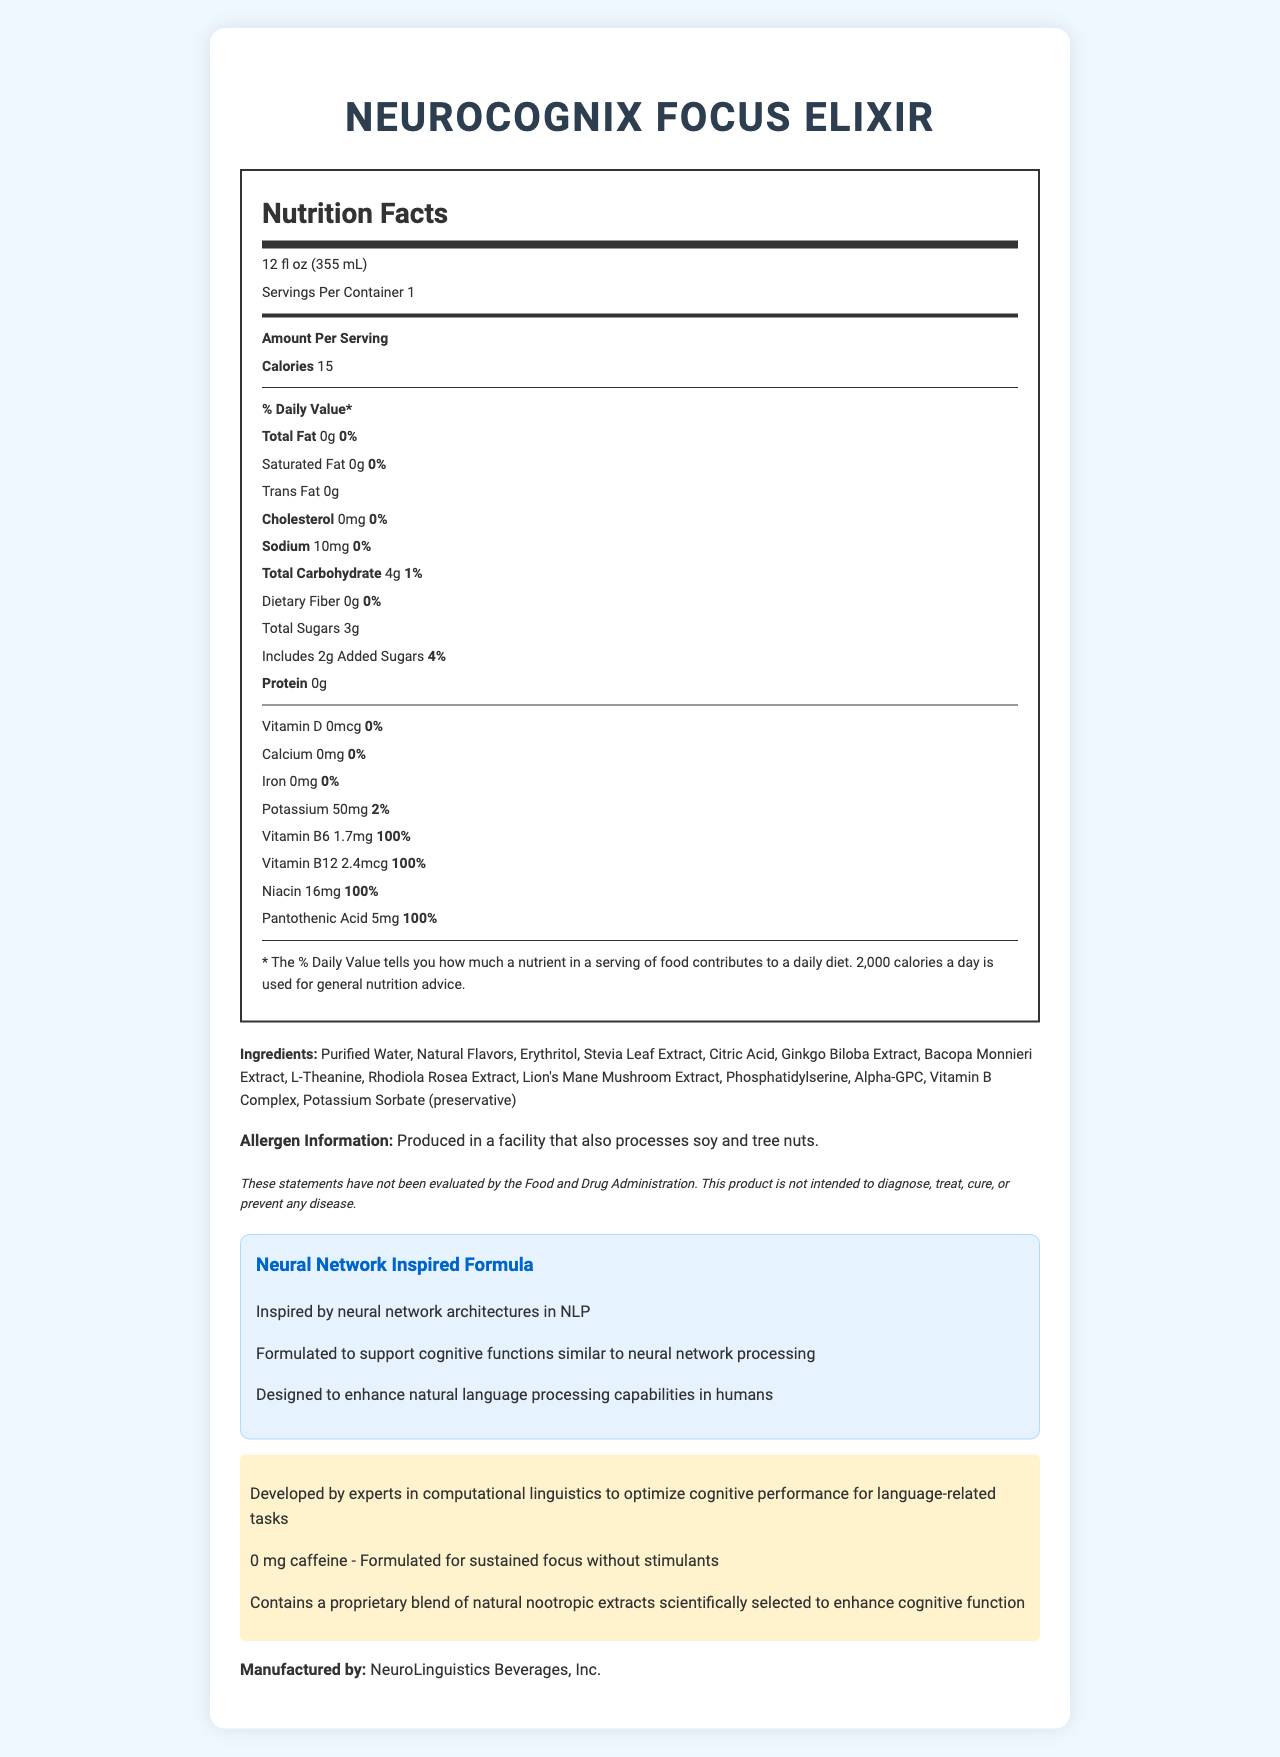What is the serving size for NeuroCognix Focus Elixir? The serving size is explicitly stated at the beginning of the nutrition facts section.
Answer: 12 fl oz (355 mL) What is the amount of total sugars per serving? Underneath the "Total Carbohydrate" section, it lists "Total Sugars 3g."
Answer: 3g How many servings are there per container? The nutrition facts state "Servings Per Container 1."
Answer: 1 What is the percentage daily value of Vitamin B12? The nutrition facts list Vitamin B12 as "100%."
Answer: 100% How much potassium is in one serving of NeuroCognix Focus Elixir? The document lists "Potassium 50mg 2%."
Answer: 50mg Which of the following natural extracts are included in the ingredients? 
A. Echinacea
B. Ginkgo Biloba Extract 
C. Green Tea Extract 
D. Rhodiola Rosea Extract The ingredients list includes "Ginkgo Biloba Extract" and "Rhodiola Rosea Extract."
Answer: B and D What is the calorie count per serving for this beverage? 
1. 0
2. 10
3. 15
4. 20 The nutrition facts state "Calories 15."
Answer: 3 Is NeuroCognix Focus Elixir caffeine-free? The highlighted section mentions "0 mg caffeine - Formulated for sustained focus without stimulants."
Answer: Yes Summarize the main idea of the document. The document comprehensively covers all aspects of the product, from basic nutritional information to the scientific inspiration behind its formulation.
Answer: This document provides the nutrition facts and additional information for NeuroCognix Focus Elixir, a caffeine-free, focus-enhancing beverage with natural extracts. It details the serving size, nutritional content, ingredients, allergen information, manufacturer, and the inspiration behind its formulation rooted in neural network architectures. Does the document mention the inclusion of any artificial preservatives? The ingredients list includes "Potassium Sorbate (preservative)," which is not specified as artificial, similar to natural extracts.
Answer: No What is the dietary fiber content in NeuroCognix Focus Elixir? The nutrition facts state "Dietary Fiber 0g."
Answer: 0g Who is the manufacturer of NeuroCognix Focus Elixir? The manufacturer is specified at the end of the document with "Manufactured by: NeuroLinguistics Beverages, Inc."
Answer: NeuroLinguistics Beverages, Inc. What is the main purpose of the proprietary blend of natural extracts in this beverage? The highlight section states "Contains a proprietary blend of natural nootropic extracts scientifically selected to enhance cognitive function."
Answer: To enhance cognitive function What is the product's connection to computational linguistics? This is explicitly mentioned in the highlighted section of the document.
Answer: Developed by experts in computational linguistics to optimize cognitive performance for language-related tasks What are the daily values of trans fat and cholesterol in NeuroCognix Focus Elixir? The nutrition facts list "Trans Fat 0g" and "Cholesterol 0mg 0%."
Answer: 0% each Does the beverage claim to diagnose, treat, cure, or prevent any disease? The disclaimer states, "This product is not intended to diagnose, treat, cure, or prevent any disease."
Answer: No What is the amount of added sugars in one serving? The nutrition facts state, "Includes 2g Added Sugars 4%."
Answer: 2g Based on the document, can we determine the exact quantity of each nootropic extract? The document only lists the natural extracts included but does not specify their individual quantities.
Answer: Not enough information 